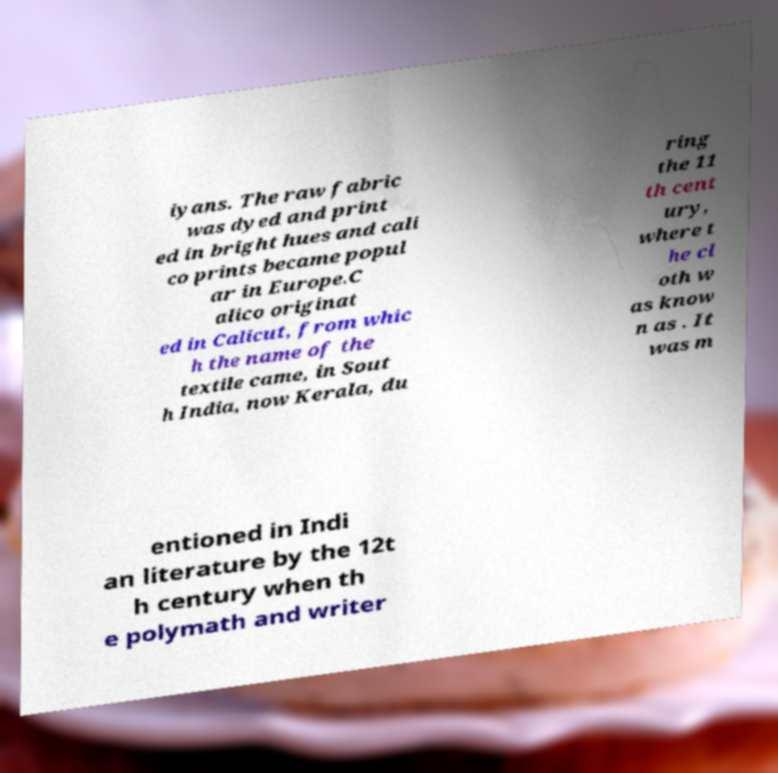There's text embedded in this image that I need extracted. Can you transcribe it verbatim? iyans. The raw fabric was dyed and print ed in bright hues and cali co prints became popul ar in Europe.C alico originat ed in Calicut, from whic h the name of the textile came, in Sout h India, now Kerala, du ring the 11 th cent ury, where t he cl oth w as know n as . It was m entioned in Indi an literature by the 12t h century when th e polymath and writer 